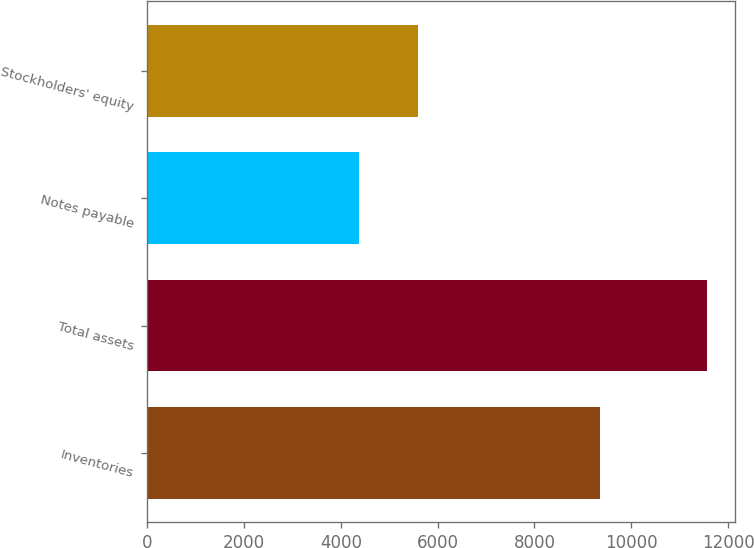Convert chart to OTSL. <chart><loc_0><loc_0><loc_500><loc_500><bar_chart><fcel>Inventories<fcel>Total assets<fcel>Notes payable<fcel>Stockholders' equity<nl><fcel>9343.5<fcel>11556.3<fcel>4376.8<fcel>5586.9<nl></chart> 